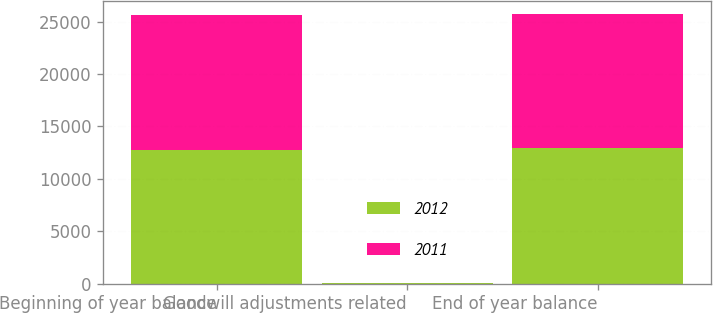Convert chart to OTSL. <chart><loc_0><loc_0><loc_500><loc_500><stacked_bar_chart><ecel><fcel>Beginning of year balance<fcel>Goodwill adjustments related<fcel>End of year balance<nl><fcel>2012<fcel>12792<fcel>13<fcel>12910<nl><fcel>2011<fcel>12805<fcel>13<fcel>12792<nl></chart> 